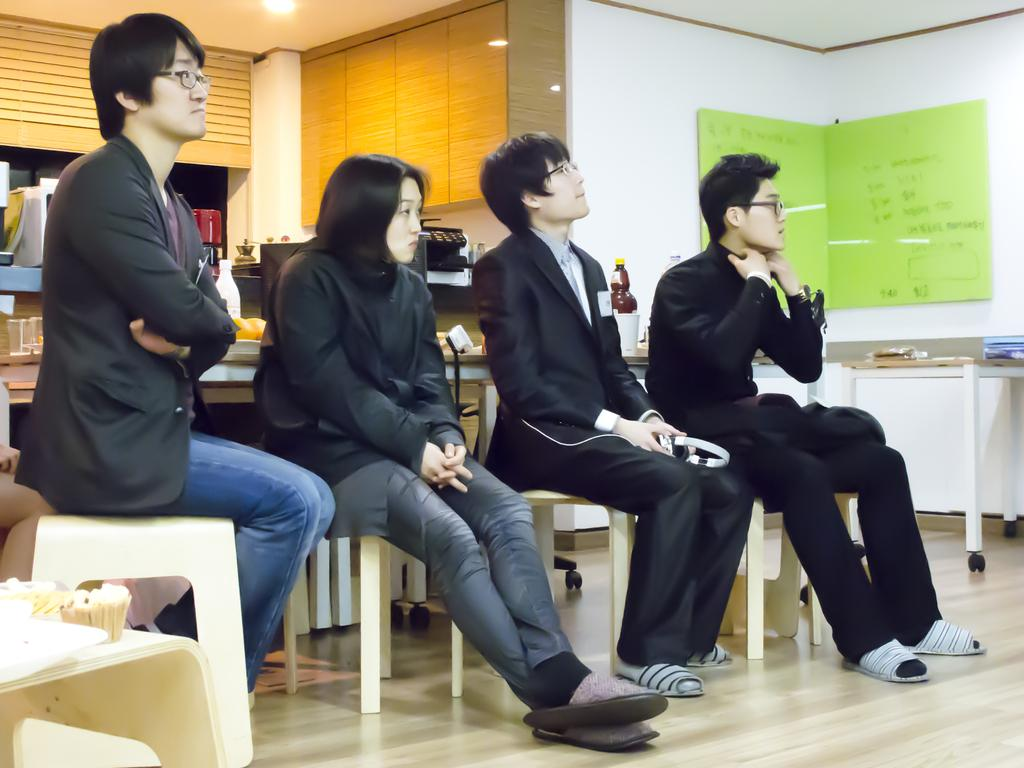How many people are sitting in chairs in the image? There are four people sitting in chairs in the image. Which direction are the people facing? The people are facing towards the right. What can be seen on the table in the image? There is a glass board and bottles visible on the table in the image. What type of objects can be found on the table? Besides the glass board and bottles, there are also books on the table. What other furniture is present in the image? There is a cupboard in the image. Are there any other objects visible in the image? Yes, there are other objects visible in the image. How many chickens are present in the image? There are no chickens present in the image. What type of hall is depicted in the image? The image does not depict a hall; it shows a group of people sitting in chairs with various objects and furniture. 